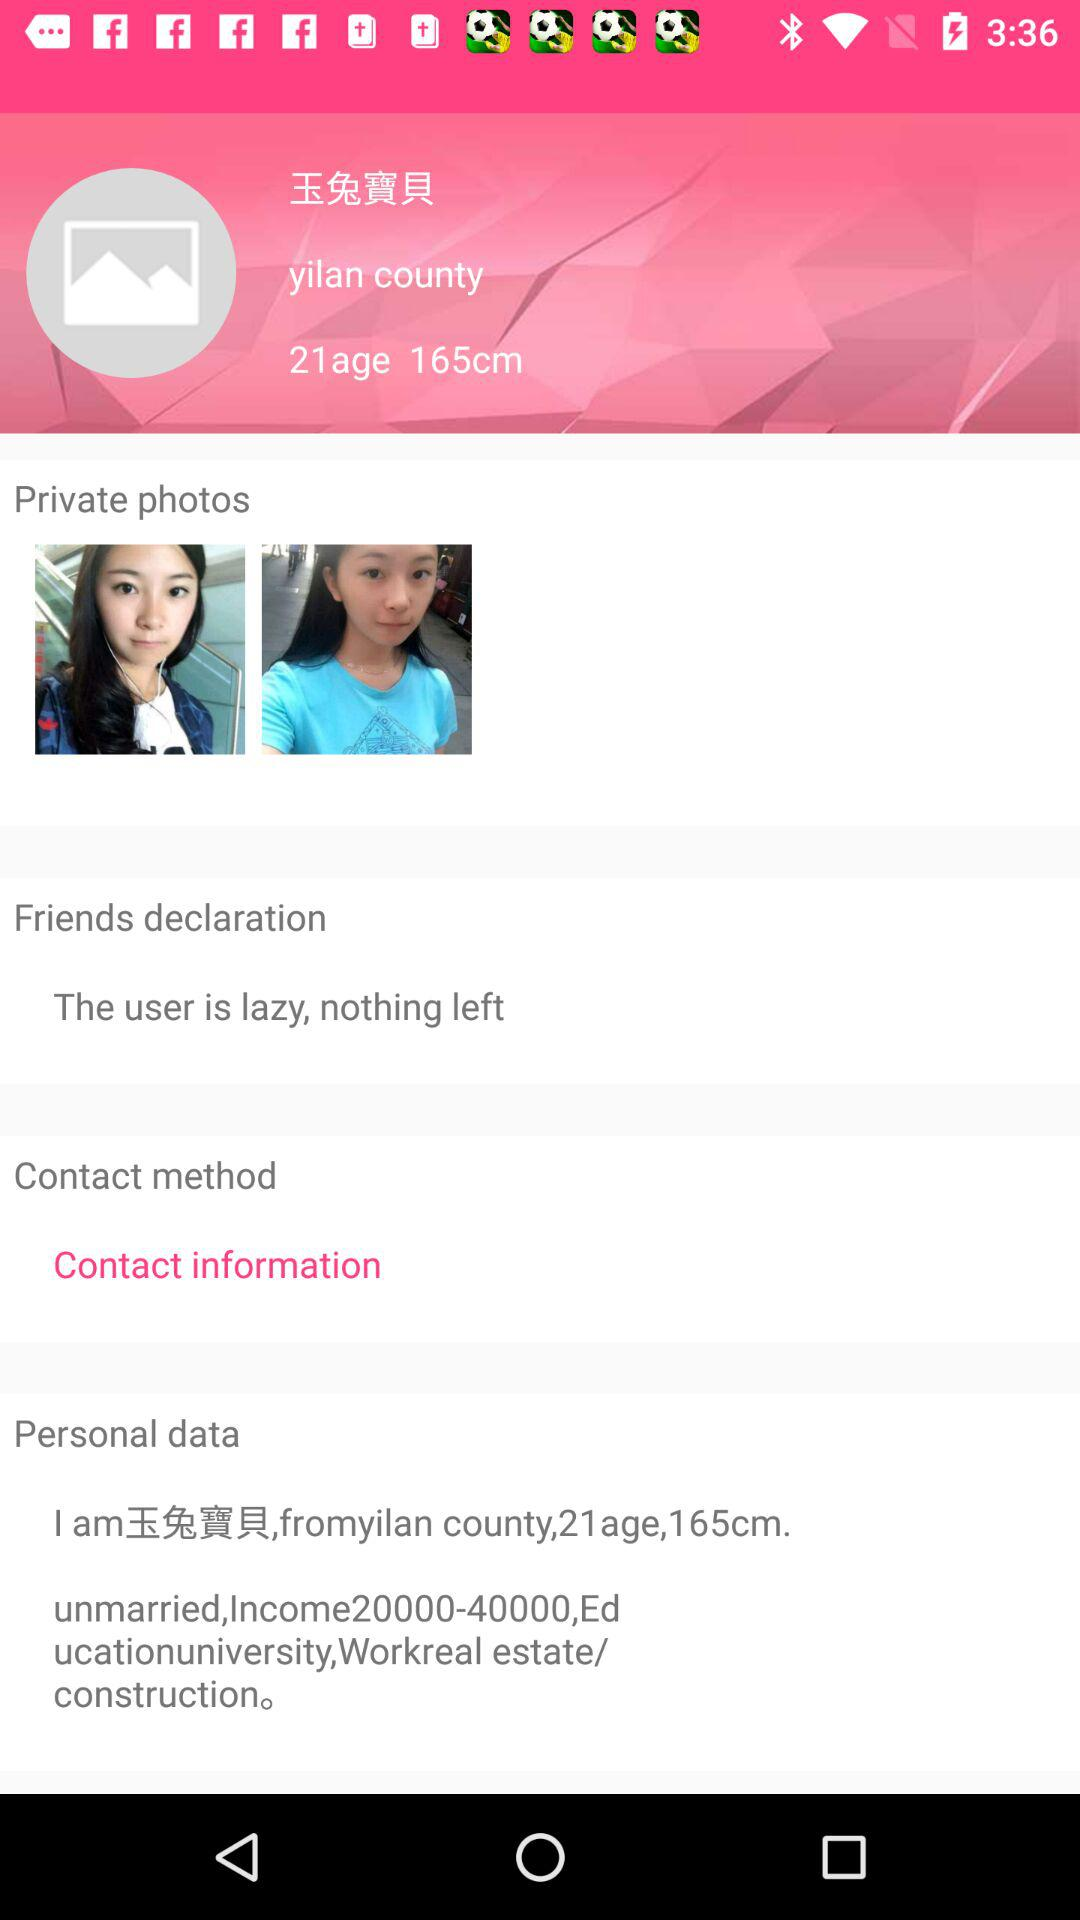How many more private photos are there than contact methods?
Answer the question using a single word or phrase. 1 